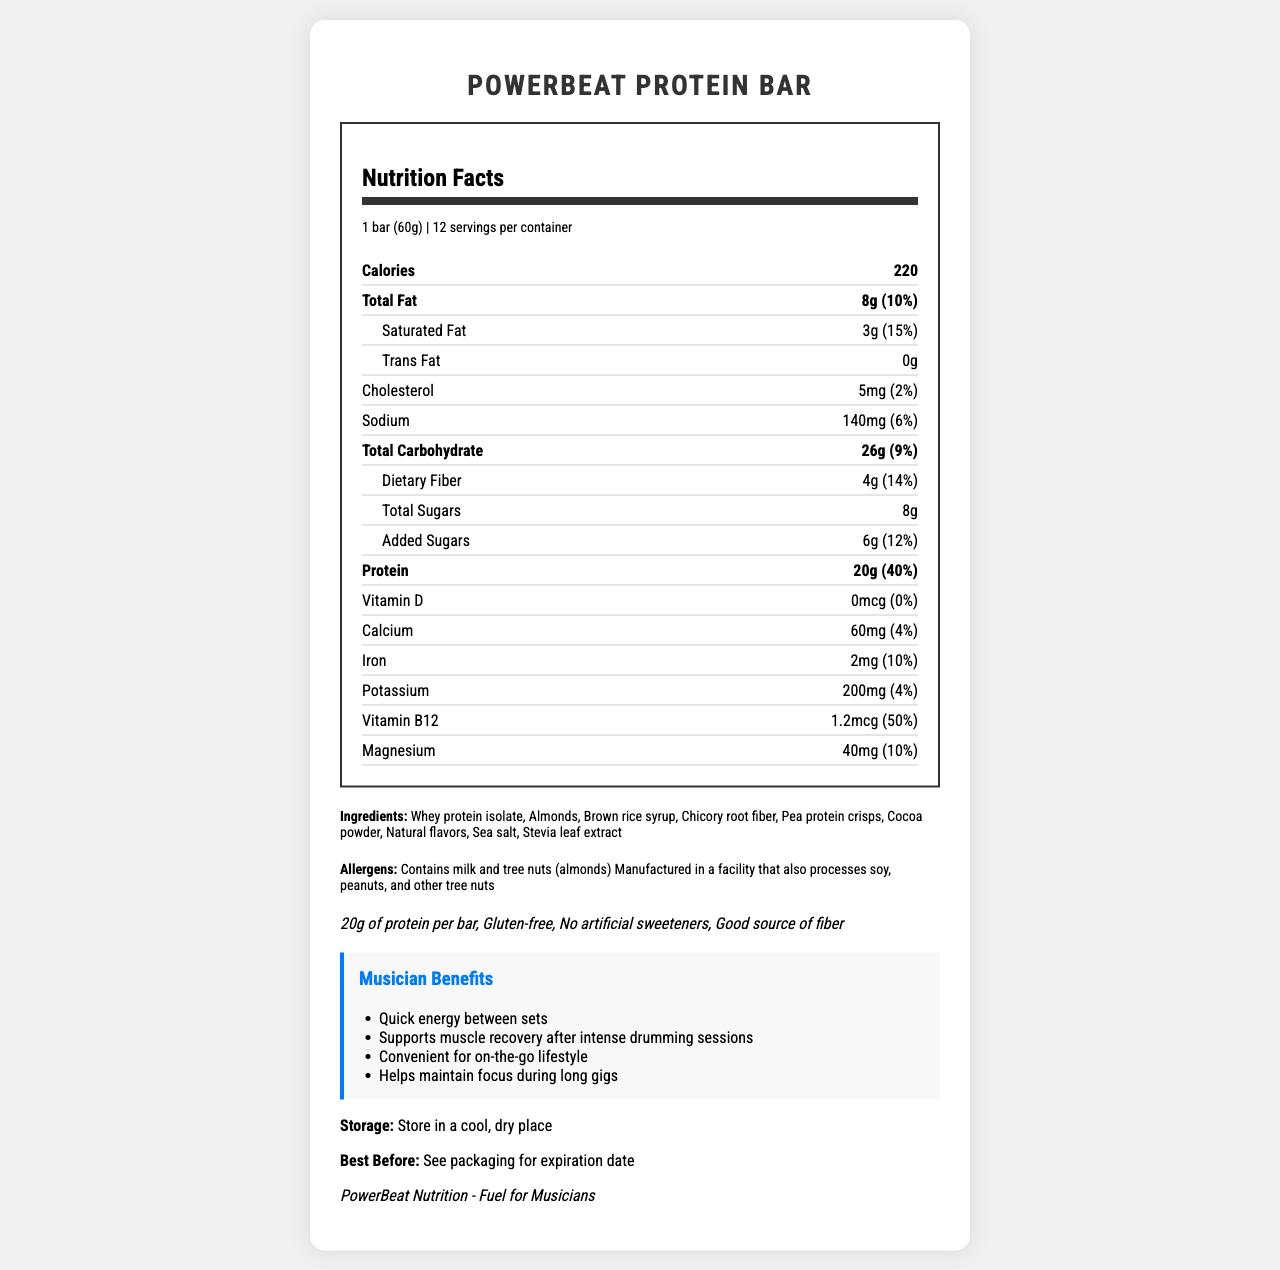what is the serving size of the PowerBeat Protein Bar? The serving size is listed under the product name as "1 bar (60g)".
Answer: 1 bar (60g) how many servings are there per container? The number of servings per container is given right below the serving size, listed as "12".
Answer: 12 what is the total fat content and its daily value percentage? The total fat content and its daily value percentage are listed in the nutrition facts section as "Total Fat 8g (10%)".
Answer: 8g, 10% how much protein does one PowerBeat Protein Bar contain? The protein content per bar is stated in the nutrition facts as "Protein 20g (40%)".
Answer: 20g name two allergens mentioned in the document. The allergens section lists "Contains milk and tree nuts (almonds)".
Answer: Milk and almonds (tree nuts) what are some benefits of the PowerBeat Protein Bar for musicians? The musician benefits section lists four benefits: quick energy between sets, supports muscle recovery, convenient for on-the-go lifestyle, and helps maintain focus during long gigs.
Answer: Quick energy between sets, Supports muscle recovery, Convenient for on-the-go lifestyle, Helps maintain focus what type of fiber is included, and how much dietary fiber is in the bar? Chicory root fiber is listed as an ingredient, and the dietary fiber content of the bar is mentioned as "Dietary Fiber 4g (14%)".
Answer: Chicory root fiber, 4g how many "total sugars" and "added sugars" are there in one bar? The nutrition facts section lists "Total Sugars 8g" and "Added Sugars 6g (12%)".
Answer: 8g total sugars, 6g added sugars what is the main sweetener used in the PowerBeat Protein Bar? Stevia leaf extract is mentioned as one of the ingredients.
Answer: Stevia leaf extract how much vitamin B12 does the bar contain, and what is its daily value percentage? The nutrition facts section lists "Vitamin B12 1.2mcg (50%)".
Answer: 1.2mcg, 50% is the PowerBeat Protein Bar gluten-free? The claims section includes "Gluten-free".
Answer: Yes does the protein bar contain artificial sweeteners? The document claims that the product has "No artificial sweeteners".
Answer: No where should the PowerBeat Protein Bar be stored? The storage recommendation is to "Store in a cool, dry place".
Answer: In a cool, dry place what is the best before date for the PowerBeat Protein Bar? The document advises to "See packaging for expiration date".
Answer: See packaging for expiration date what brand produces the PowerBeat Protein Bar and what is their target audience? The brand information reveals the brand as "PowerBeat Nutrition - Fuel for Musicians".
Answer: PowerBeat Nutrition - Fuel for Musicians does the PowerBeat Protein Bar contain any cholesterol? The nutrition facts show a cholesterol content of "5mg (2%)".
Answer: Yes which nutrient has the highest daily value percentage per bar? A. Total Fat B. Protein C. Vitamin B12 D. Iron The protein content has the highest daily value percentage at 40%.
Answer: B which ingredient is not part of the PowerBeat Protein Bar? A. Whey protein isolate B. Almonds C. Brown sugar D. Stevia leaf extract The document lists whey protein isolate, almonds, and stevia leaf extract as ingredients but not brown sugar.
Answer: C is the PowerBeat Protein Bar suitable for vegans? The bar contains whey protein isolate (milk), making it unsuitable for vegans.
Answer: No what are the main components showcased in the PowerBeat Protein Bar's nutrition facts? The nutrition facts include various nutrients, listing their amounts and daily value percentages.
Answer: Calories, total fat, saturated fat, trans fat, cholesterol, sodium, total carbohydrate, dietary fiber, total sugars, added sugars, protein, vitamin D, calcium, iron, potassium, vitamin B12, magnesium how many calories are there per serving, and how does this benefit a musician's routine? The bar contains 220 calories, which helps provide quick energy, aid in muscle recovery, and maintain focus during performances.
Answer: 220 calories, Provides quick energy between sets, supports muscle recovery, maintains focus during long gigs which nutrient's daily value percentage is not provided? All the nutrients listed have their daily value percentages provided.
Answer: Not enough information describe the main idea of the document. The document provides comprehensive nutritional information about the PowerBeat Protein Bar and emphasizes its benefits for musicians, making it a suitable quick meal option between gigs and for maintaining performance energy and focus.
Answer: The document is a Nutrition Facts Label for the PowerBeat Protein Bar, highlighting its nutritional content, ingredients, allergens, and benefits for musicians. It includes detailed information about each nutrient's amount and daily value percentage, as well as claims about being gluten-free and containing no artificial sweeteners. The document also explains storage instructions and mentions the benefits specifically catered to musicians, such as quick energy and muscle recovery support. 